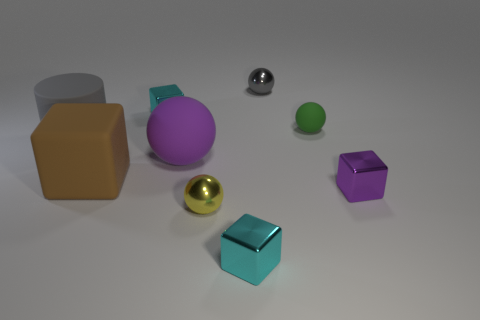The small metal cube on the left side of the cyan cube on the right side of the block behind the big rubber ball is what color?
Ensure brevity in your answer.  Cyan. There is a cyan shiny object behind the large gray thing; are there any big purple objects that are behind it?
Offer a terse response. No. Do the tiny metal cube that is to the right of the tiny gray metallic object and the matte sphere that is to the left of the small gray ball have the same color?
Ensure brevity in your answer.  Yes. What number of cyan shiny objects have the same size as the purple matte thing?
Make the answer very short. 0. There is a metallic ball on the right side of the yellow thing; does it have the same size as the green object?
Your answer should be compact. Yes. What is the shape of the purple shiny thing?
Your answer should be compact. Cube. What is the size of the object that is the same color as the big ball?
Ensure brevity in your answer.  Small. Is the material of the cyan cube that is behind the tiny purple cube the same as the small gray ball?
Your answer should be very brief. Yes. Are there any cubes of the same color as the cylinder?
Offer a terse response. No. There is a thing that is left of the brown matte thing; does it have the same shape as the cyan shiny object that is in front of the brown block?
Your answer should be compact. No. 